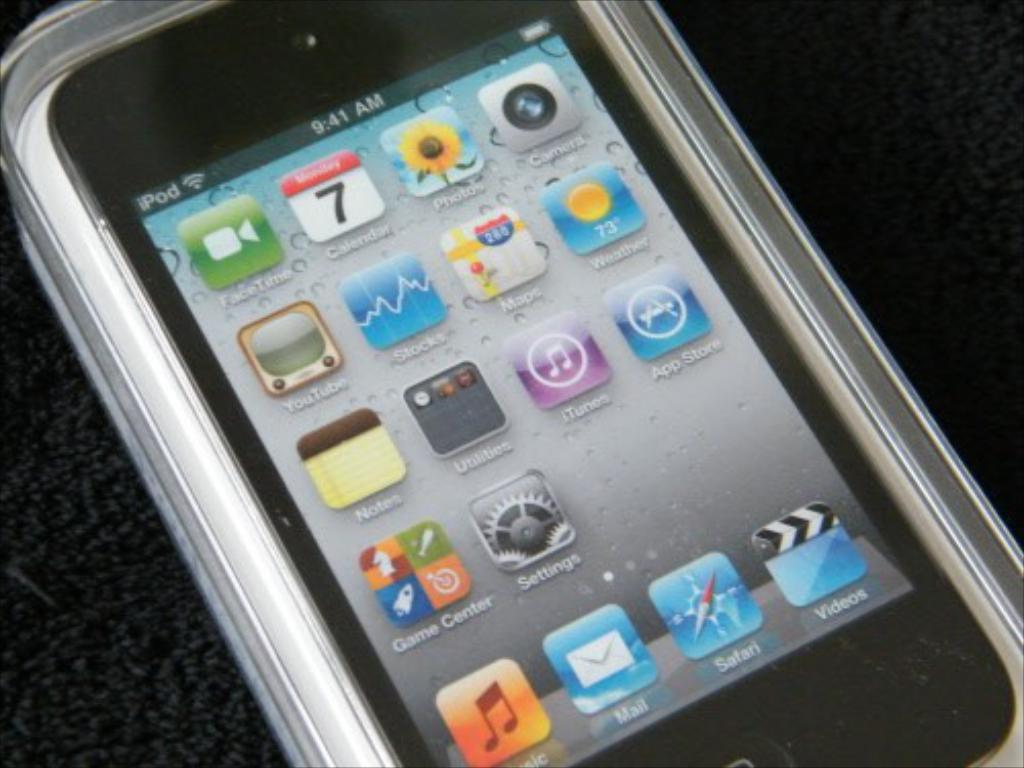Provide a one-sentence caption for the provided image. A phone which shows that it is the 7th of the current month. 